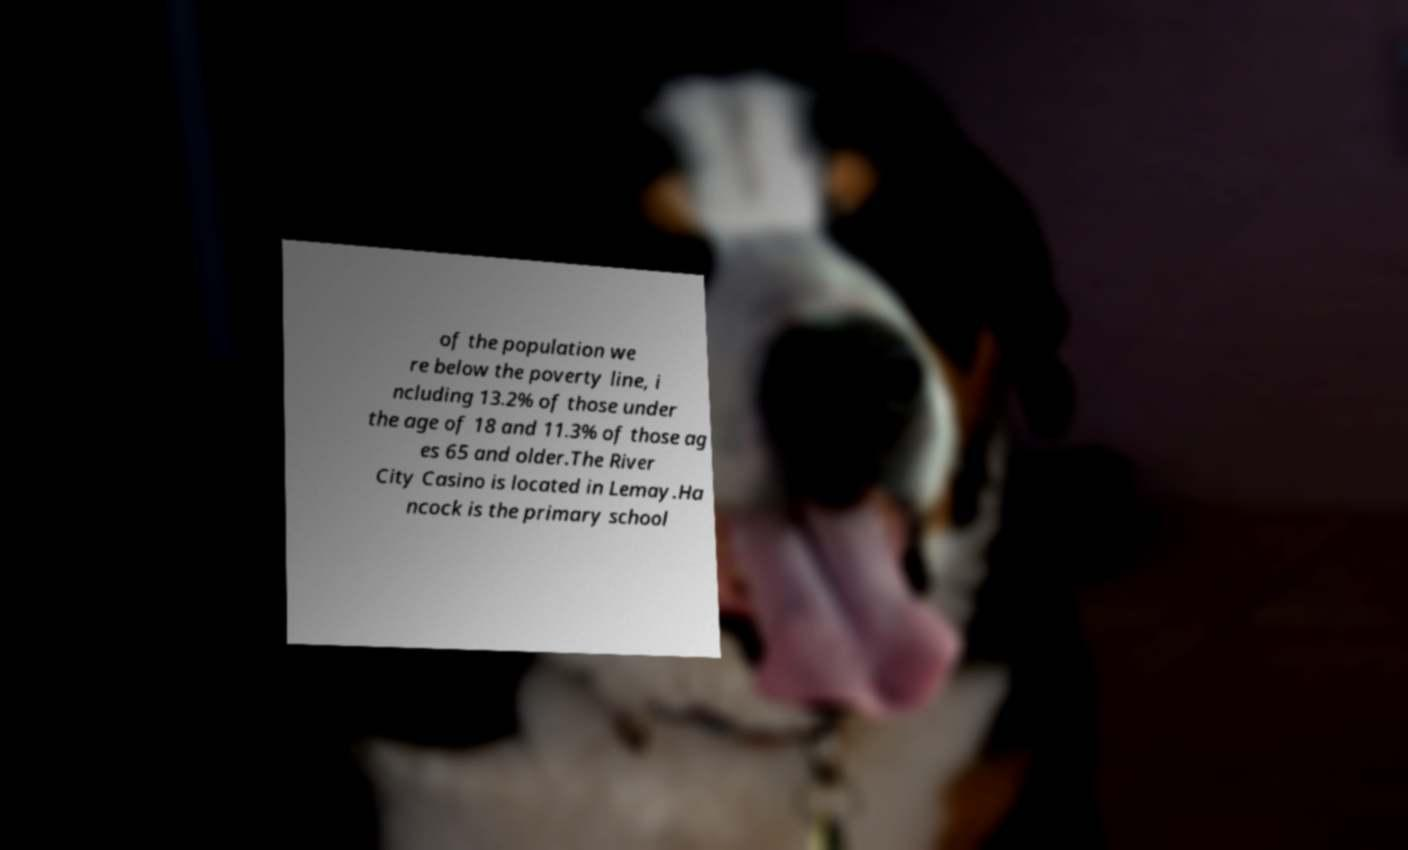I need the written content from this picture converted into text. Can you do that? of the population we re below the poverty line, i ncluding 13.2% of those under the age of 18 and 11.3% of those ag es 65 and older.The River City Casino is located in Lemay.Ha ncock is the primary school 